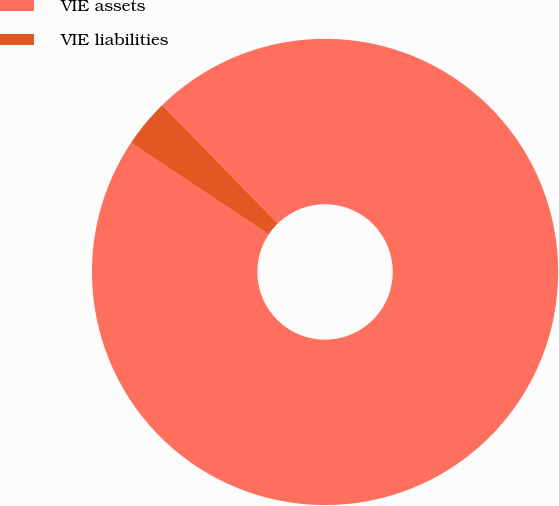Convert chart to OTSL. <chart><loc_0><loc_0><loc_500><loc_500><pie_chart><fcel>VIE assets<fcel>VIE liabilities<nl><fcel>96.65%<fcel>3.35%<nl></chart> 